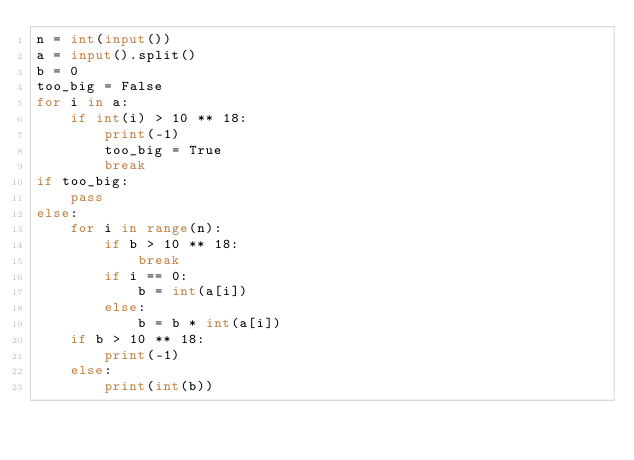Convert code to text. <code><loc_0><loc_0><loc_500><loc_500><_Python_>n = int(input())
a = input().split()
b = 0
too_big = False
for i in a:
    if int(i) > 10 ** 18:
        print(-1)
        too_big = True
        break
if too_big:
    pass
else:
    for i in range(n):
        if b > 10 ** 18:
            break
        if i == 0:
            b = int(a[i])
        else:
            b = b * int(a[i])
    if b > 10 ** 18:
        print(-1)
    else:
        print(int(b))</code> 